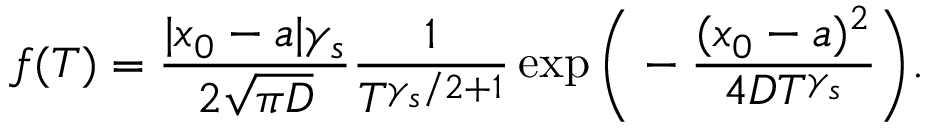Convert formula to latex. <formula><loc_0><loc_0><loc_500><loc_500>f ( T ) = \frac { | x _ { 0 } - a | \gamma _ { s } } { 2 \sqrt { \pi D } } \frac { 1 } { T ^ { \gamma _ { s } / 2 + 1 } } \exp \left ( - \frac { ( x _ { 0 } - a ) ^ { 2 } } { 4 D T ^ { \gamma _ { s } } } \right ) .</formula> 